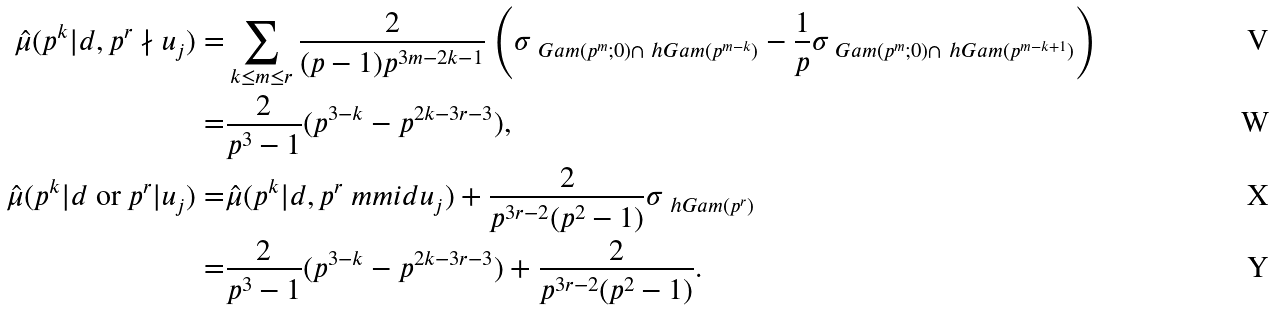<formula> <loc_0><loc_0><loc_500><loc_500>\hat { \mu } ( p ^ { k } | d , p ^ { r } \nmid u _ { j } ) = & \sum _ { k \leq m \leq r } \frac { 2 } { ( p - 1 ) p ^ { 3 m - 2 k - 1 } } \left ( \sigma _ { \ G a m ( p ^ { m } ; 0 ) \cap \ h G a m ( p ^ { m - k } ) } - \frac { 1 } { p } \sigma _ { \ G a m ( p ^ { m } ; 0 ) \cap \ h G a m ( p ^ { m - k + 1 } ) } \right ) \\ = & \frac { 2 } { p ^ { 3 } - 1 } ( p ^ { 3 - k } - p ^ { 2 k - 3 r - 3 } ) , \\ \hat { \mu } ( \text {$p^{k}| d$ or $p^{r}| u_{j}$} ) = & \hat { \mu } ( p ^ { k } | d , p ^ { r } \ m m i d u _ { j } ) + \frac { 2 } { p ^ { 3 r - 2 } ( p ^ { 2 } - 1 ) } \sigma _ { \ h G a m ( p ^ { r } ) } \\ = & \frac { 2 } { p ^ { 3 } - 1 } ( p ^ { 3 - k } - p ^ { 2 k - 3 r - 3 } ) + \frac { 2 } { p ^ { 3 r - 2 } ( p ^ { 2 } - 1 ) } .</formula> 